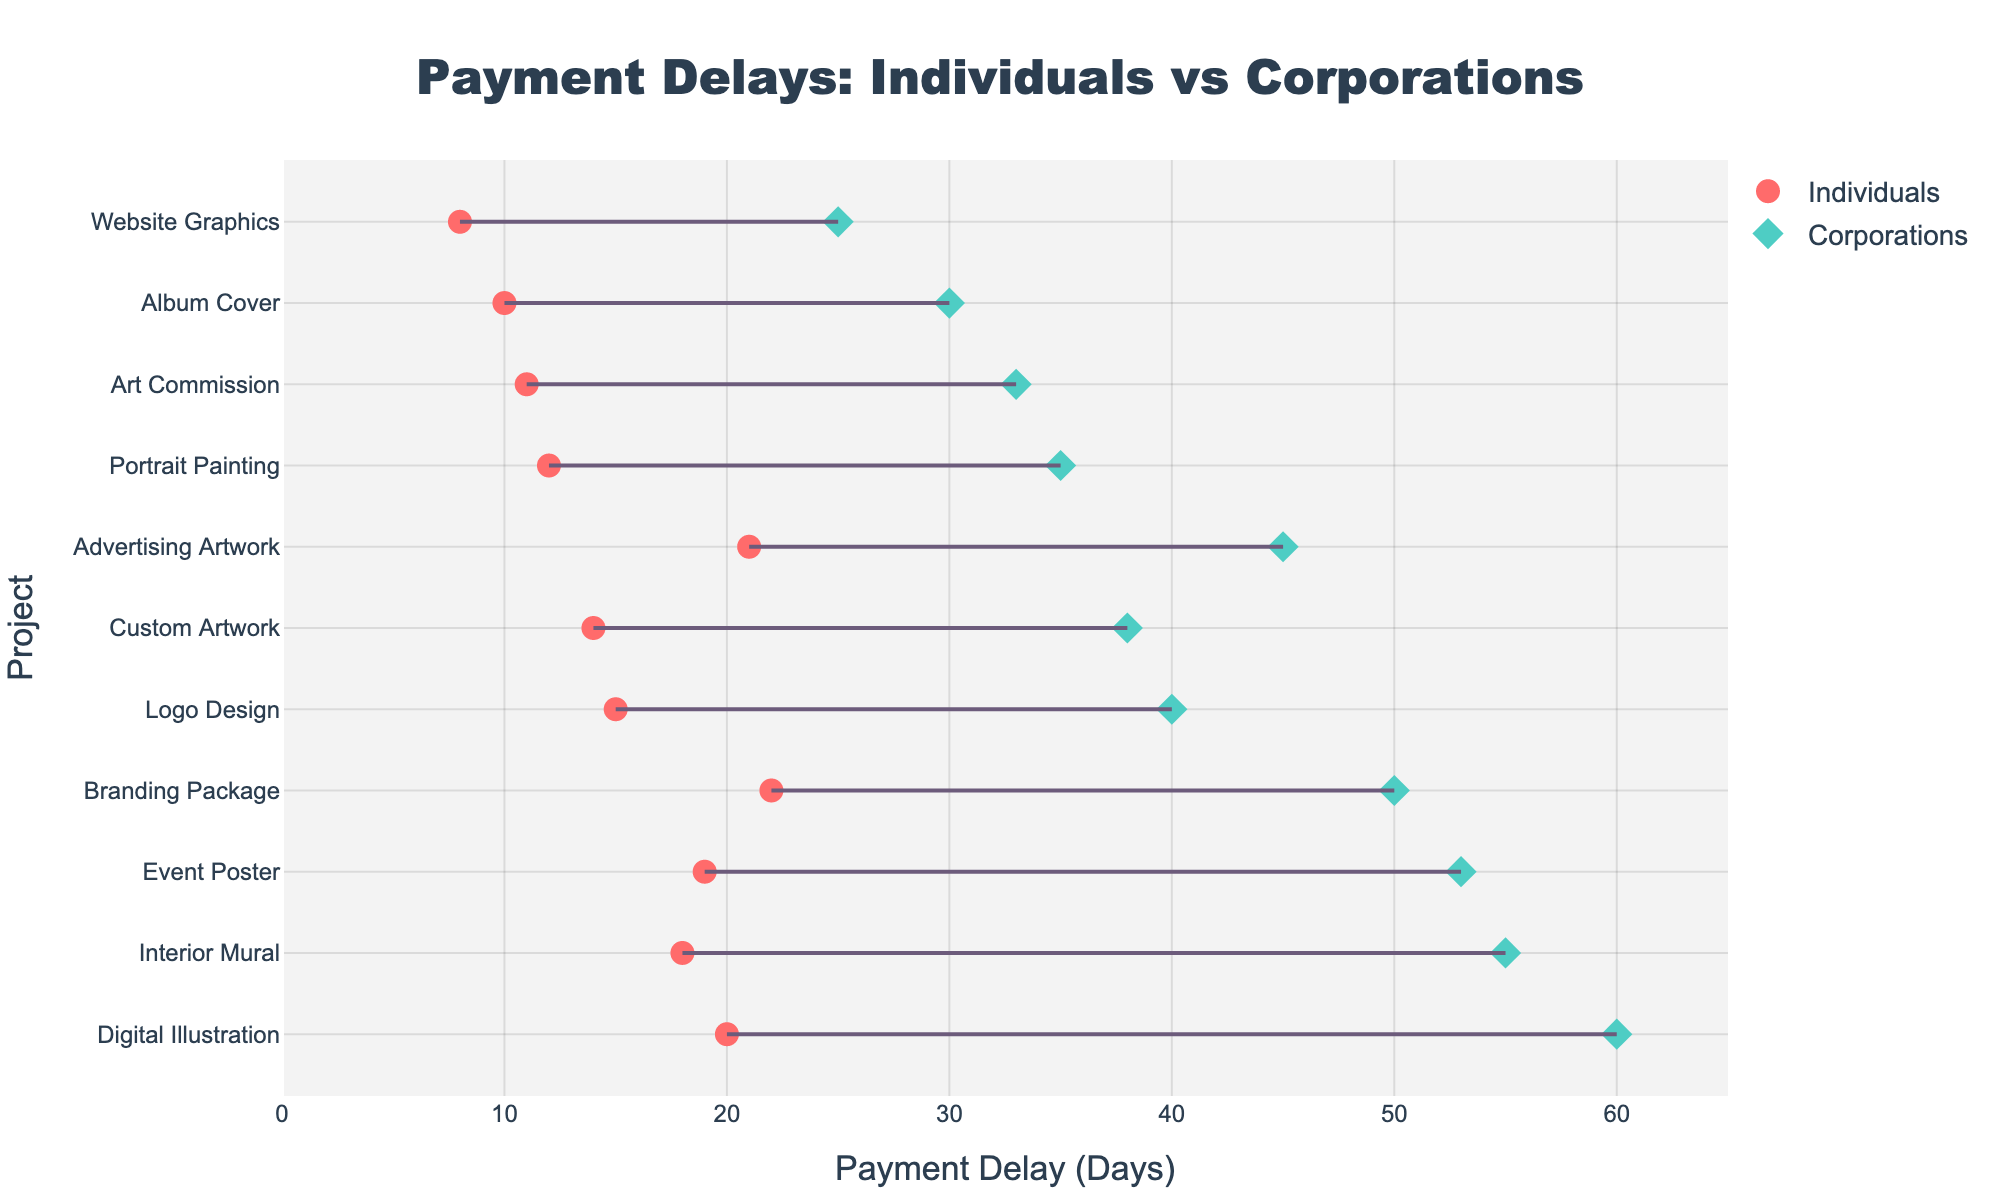What is the title of the plot? The title is located at the top center of the plot, and it provides an overview of what the plot is about. The title of the plot gives context to the data being displayed.
Answer: Payment Delays: Individuals vs Corporations How many projects are displayed in the plot? Count the total number of data points/projects listed on the y-axis.
Answer: 11 Which project has the smallest payment delay for individuals? Look for the project with the smallest x-value for the 'Individuals' markers (shown with circles).
Answer: Website Graphics What's the range of payment delays for corporations? Identify the minimum and maximum x-values for the 'Corporations' markers (shown with diamonds) and calculate the range. The values are from 25 to 60 days.
Answer: 35 days Which project has the largest difference in payment delays between individuals and corporations? Find the project where the connecting line between 'Individuals' and 'Corporations' markers is the longest. This would be the project with the largest vertical distance.
Answer: Digital Illustration Which type of client generally has longer payment delays? Compare the general positions of the 'Individuals' markers (circles) with the 'Corporations' markers (diamonds). Since most corporation markers are to the right of the individual markers, corporations generally have longer payment delays.
Answer: Corporations What is the average payment delay for individuals across all projects? Sum all the individual delays and divide by the number of projects: (15+12+18+10+20+8+22+11+19+14+21) / 11 = 170 / 11.
Answer: 15.45 days Which project has the closest payment delays for individuals and corporations? Find the project where the connecting line is the shortest, indicating the smallest difference.
Answer: Custom Artwork Which project has the longest payment delay for corporations? Identify the project with the highest x-value for the 'Corporations' markers.
Answer: Digital Illustration Are payment delays more consistent for individuals or corporations across different projects? Compare the spread of the 'Individuals' markers with the 'Corporations' markers. A larger spread indicates less consistency. The markers for corporations are spread out more widely, suggesting less consistency.
Answer: Individuals 